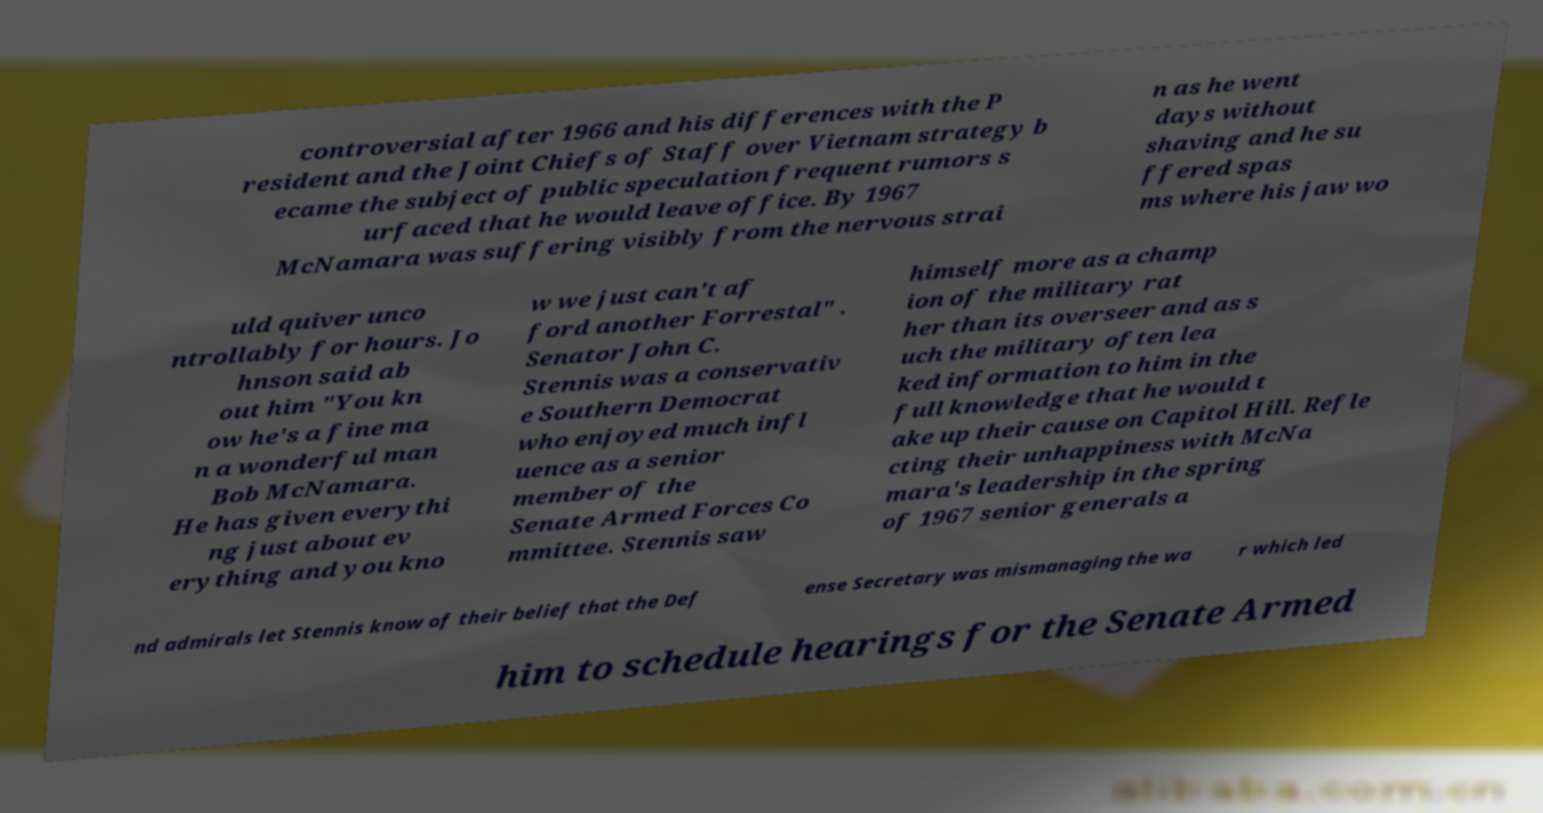For documentation purposes, I need the text within this image transcribed. Could you provide that? controversial after 1966 and his differences with the P resident and the Joint Chiefs of Staff over Vietnam strategy b ecame the subject of public speculation frequent rumors s urfaced that he would leave office. By 1967 McNamara was suffering visibly from the nervous strai n as he went days without shaving and he su ffered spas ms where his jaw wo uld quiver unco ntrollably for hours. Jo hnson said ab out him "You kn ow he's a fine ma n a wonderful man Bob McNamara. He has given everythi ng just about ev erything and you kno w we just can't af ford another Forrestal" . Senator John C. Stennis was a conservativ e Southern Democrat who enjoyed much infl uence as a senior member of the Senate Armed Forces Co mmittee. Stennis saw himself more as a champ ion of the military rat her than its overseer and as s uch the military often lea ked information to him in the full knowledge that he would t ake up their cause on Capitol Hill. Refle cting their unhappiness with McNa mara's leadership in the spring of 1967 senior generals a nd admirals let Stennis know of their belief that the Def ense Secretary was mismanaging the wa r which led him to schedule hearings for the Senate Armed 